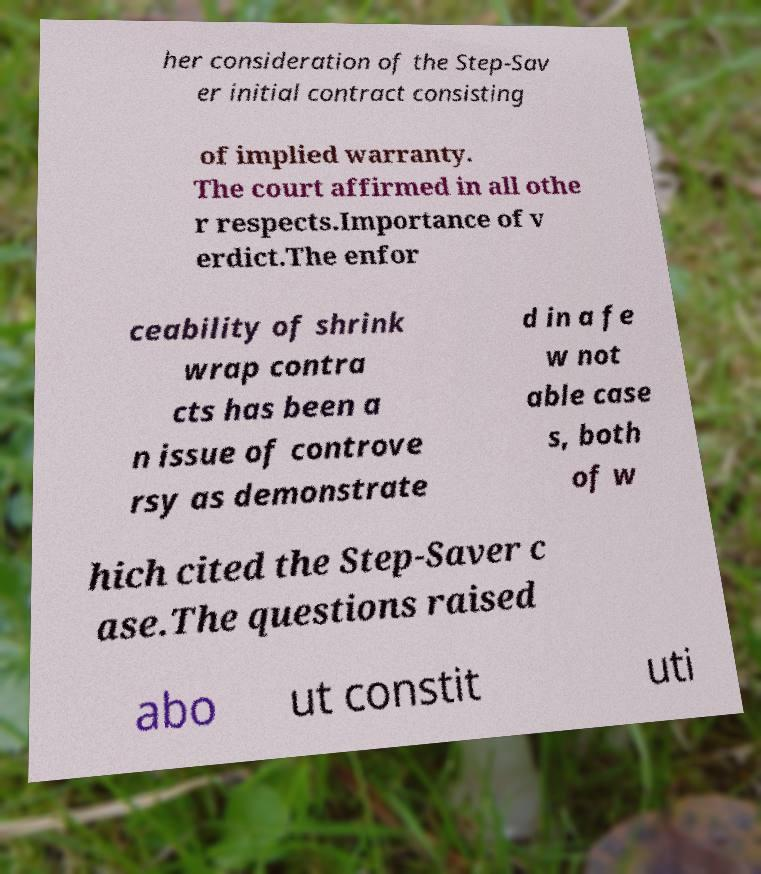Please identify and transcribe the text found in this image. her consideration of the Step-Sav er initial contract consisting of implied warranty. The court affirmed in all othe r respects.Importance of v erdict.The enfor ceability of shrink wrap contra cts has been a n issue of controve rsy as demonstrate d in a fe w not able case s, both of w hich cited the Step-Saver c ase.The questions raised abo ut constit uti 